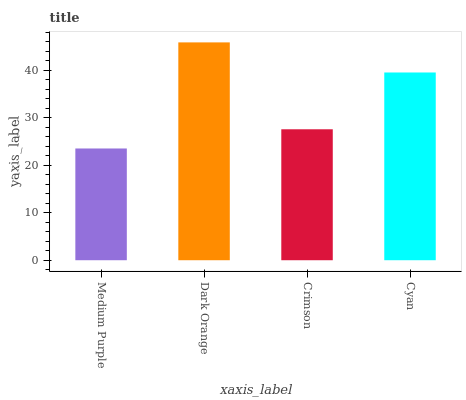Is Medium Purple the minimum?
Answer yes or no. Yes. Is Dark Orange the maximum?
Answer yes or no. Yes. Is Crimson the minimum?
Answer yes or no. No. Is Crimson the maximum?
Answer yes or no. No. Is Dark Orange greater than Crimson?
Answer yes or no. Yes. Is Crimson less than Dark Orange?
Answer yes or no. Yes. Is Crimson greater than Dark Orange?
Answer yes or no. No. Is Dark Orange less than Crimson?
Answer yes or no. No. Is Cyan the high median?
Answer yes or no. Yes. Is Crimson the low median?
Answer yes or no. Yes. Is Dark Orange the high median?
Answer yes or no. No. Is Cyan the low median?
Answer yes or no. No. 